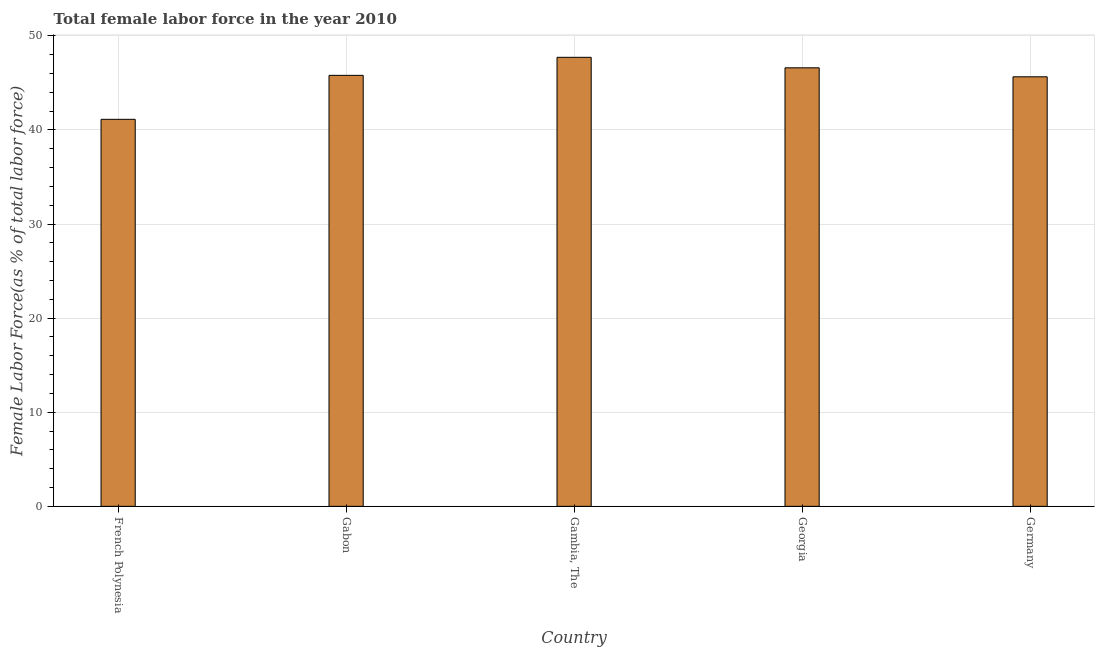Does the graph contain any zero values?
Ensure brevity in your answer.  No. Does the graph contain grids?
Your response must be concise. Yes. What is the title of the graph?
Your answer should be compact. Total female labor force in the year 2010. What is the label or title of the Y-axis?
Provide a succinct answer. Female Labor Force(as % of total labor force). What is the total female labor force in Georgia?
Keep it short and to the point. 46.6. Across all countries, what is the maximum total female labor force?
Give a very brief answer. 47.72. Across all countries, what is the minimum total female labor force?
Keep it short and to the point. 41.13. In which country was the total female labor force maximum?
Ensure brevity in your answer.  Gambia, The. In which country was the total female labor force minimum?
Make the answer very short. French Polynesia. What is the sum of the total female labor force?
Your answer should be very brief. 226.9. What is the difference between the total female labor force in French Polynesia and Georgia?
Your answer should be compact. -5.47. What is the average total female labor force per country?
Offer a very short reply. 45.38. What is the median total female labor force?
Ensure brevity in your answer.  45.8. In how many countries, is the total female labor force greater than 8 %?
Your answer should be very brief. 5. What is the ratio of the total female labor force in Gabon to that in Georgia?
Your answer should be compact. 0.98. Is the total female labor force in Gabon less than that in Germany?
Ensure brevity in your answer.  No. Is the difference between the total female labor force in French Polynesia and Gambia, The greater than the difference between any two countries?
Your response must be concise. Yes. What is the difference between the highest and the second highest total female labor force?
Keep it short and to the point. 1.12. Is the sum of the total female labor force in French Polynesia and Germany greater than the maximum total female labor force across all countries?
Your response must be concise. Yes. What is the difference between the highest and the lowest total female labor force?
Ensure brevity in your answer.  6.59. Are all the bars in the graph horizontal?
Your answer should be compact. No. Are the values on the major ticks of Y-axis written in scientific E-notation?
Provide a short and direct response. No. What is the Female Labor Force(as % of total labor force) in French Polynesia?
Give a very brief answer. 41.13. What is the Female Labor Force(as % of total labor force) of Gabon?
Offer a very short reply. 45.8. What is the Female Labor Force(as % of total labor force) of Gambia, The?
Offer a very short reply. 47.72. What is the Female Labor Force(as % of total labor force) of Georgia?
Your answer should be compact. 46.6. What is the Female Labor Force(as % of total labor force) in Germany?
Keep it short and to the point. 45.65. What is the difference between the Female Labor Force(as % of total labor force) in French Polynesia and Gabon?
Give a very brief answer. -4.67. What is the difference between the Female Labor Force(as % of total labor force) in French Polynesia and Gambia, The?
Your answer should be compact. -6.59. What is the difference between the Female Labor Force(as % of total labor force) in French Polynesia and Georgia?
Keep it short and to the point. -5.47. What is the difference between the Female Labor Force(as % of total labor force) in French Polynesia and Germany?
Give a very brief answer. -4.52. What is the difference between the Female Labor Force(as % of total labor force) in Gabon and Gambia, The?
Your response must be concise. -1.92. What is the difference between the Female Labor Force(as % of total labor force) in Gabon and Georgia?
Provide a succinct answer. -0.8. What is the difference between the Female Labor Force(as % of total labor force) in Gabon and Germany?
Give a very brief answer. 0.15. What is the difference between the Female Labor Force(as % of total labor force) in Gambia, The and Georgia?
Offer a terse response. 1.12. What is the difference between the Female Labor Force(as % of total labor force) in Gambia, The and Germany?
Provide a short and direct response. 2.07. What is the difference between the Female Labor Force(as % of total labor force) in Georgia and Germany?
Offer a very short reply. 0.95. What is the ratio of the Female Labor Force(as % of total labor force) in French Polynesia to that in Gabon?
Give a very brief answer. 0.9. What is the ratio of the Female Labor Force(as % of total labor force) in French Polynesia to that in Gambia, The?
Keep it short and to the point. 0.86. What is the ratio of the Female Labor Force(as % of total labor force) in French Polynesia to that in Georgia?
Your answer should be very brief. 0.88. What is the ratio of the Female Labor Force(as % of total labor force) in French Polynesia to that in Germany?
Keep it short and to the point. 0.9. What is the ratio of the Female Labor Force(as % of total labor force) in Gabon to that in Gambia, The?
Your answer should be compact. 0.96. What is the ratio of the Female Labor Force(as % of total labor force) in Gabon to that in Georgia?
Provide a succinct answer. 0.98. What is the ratio of the Female Labor Force(as % of total labor force) in Gambia, The to that in Georgia?
Provide a short and direct response. 1.02. What is the ratio of the Female Labor Force(as % of total labor force) in Gambia, The to that in Germany?
Keep it short and to the point. 1.04. 